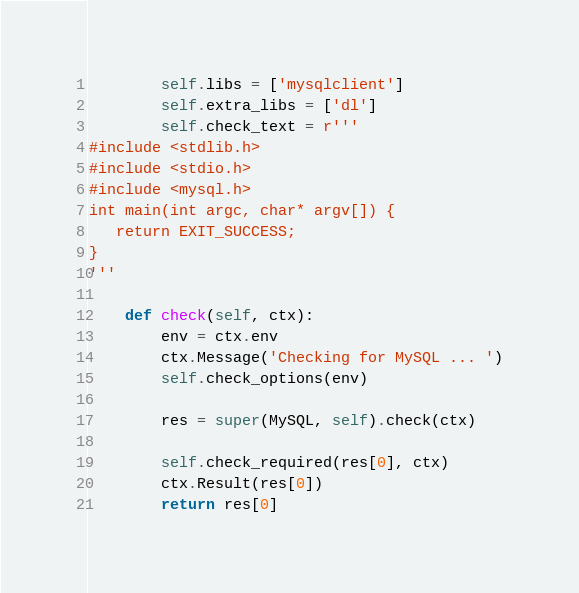<code> <loc_0><loc_0><loc_500><loc_500><_Python_>        self.libs = ['mysqlclient']
        self.extra_libs = ['dl']
        self.check_text = r'''
#include <stdlib.h>
#include <stdio.h>
#include <mysql.h>
int main(int argc, char* argv[]) {
   return EXIT_SUCCESS;
}
'''

    def check(self, ctx):
        env = ctx.env
        ctx.Message('Checking for MySQL ... ')
        self.check_options(env)

        res = super(MySQL, self).check(ctx)

        self.check_required(res[0], ctx)
        ctx.Result(res[0])
        return res[0]
</code> 